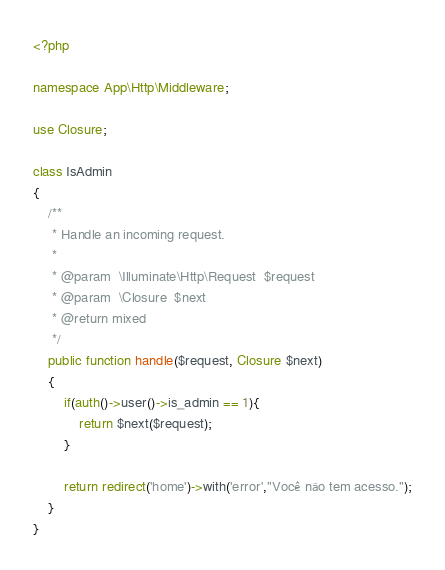<code> <loc_0><loc_0><loc_500><loc_500><_PHP_><?php
  
namespace App\Http\Middleware;
  
use Closure;
   
class IsAdmin
{
    /**
     * Handle an incoming request.
     *
     * @param  \Illuminate\Http\Request  $request
     * @param  \Closure  $next
     * @return mixed
     */
    public function handle($request, Closure $next)
    {
        if(auth()->user()->is_admin == 1){
            return $next($request);
        }
   
        return redirect('home')->with('error',"Você não tem acesso.");
    }
}</code> 